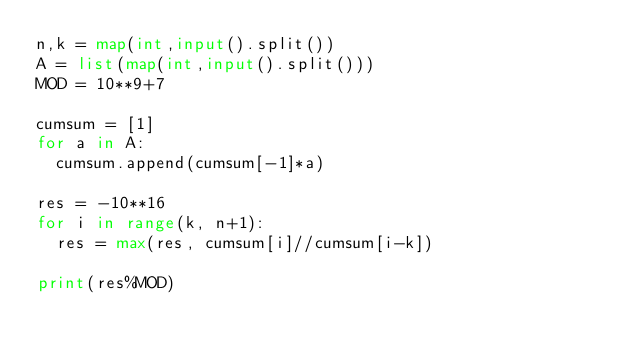Convert code to text. <code><loc_0><loc_0><loc_500><loc_500><_Python_>n,k = map(int,input().split())
A = list(map(int,input().split()))
MOD = 10**9+7

cumsum = [1]
for a in A:
  cumsum.append(cumsum[-1]*a)

res = -10**16
for i in range(k, n+1):
  res = max(res, cumsum[i]//cumsum[i-k])

print(res%MOD)</code> 